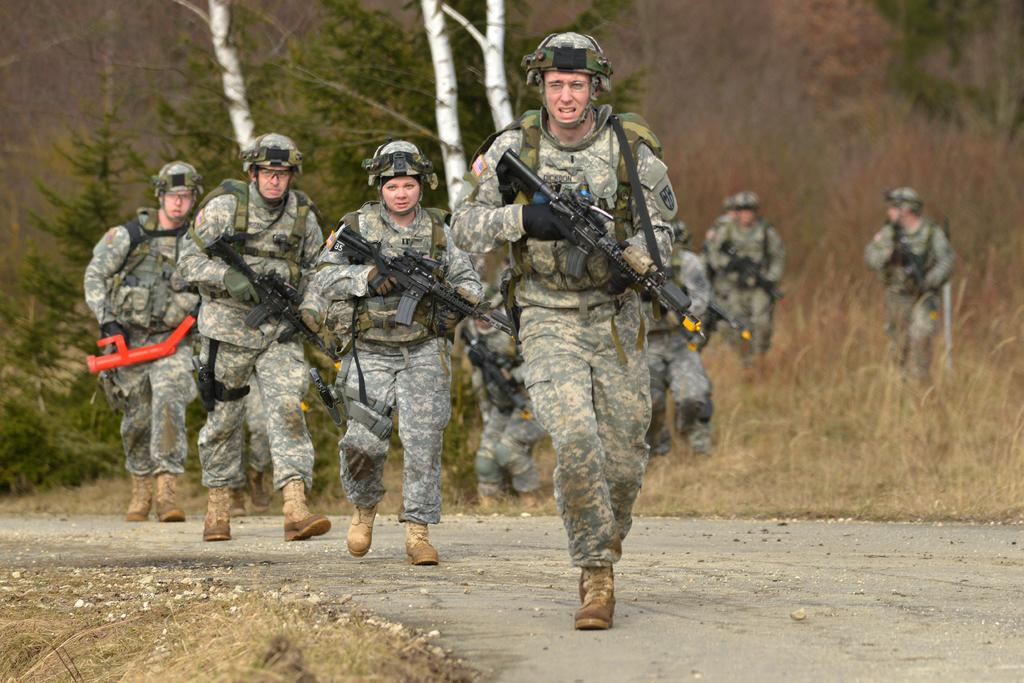What are the persons in the image doing? The persons in the image are running on the road. What are the persons holding while running? The persons are holding guns. What can be seen in the background of the image? There are trees and plants in the background of the image. Are there any other people visible in the image? Yes, there are other persons in the background of the image. Can you tell me what type of kitty is requesting the substance in the image? There is no kitty or substance present in the image. What type of request is the kitty making in the image? There is no kitty or request present in the image. 